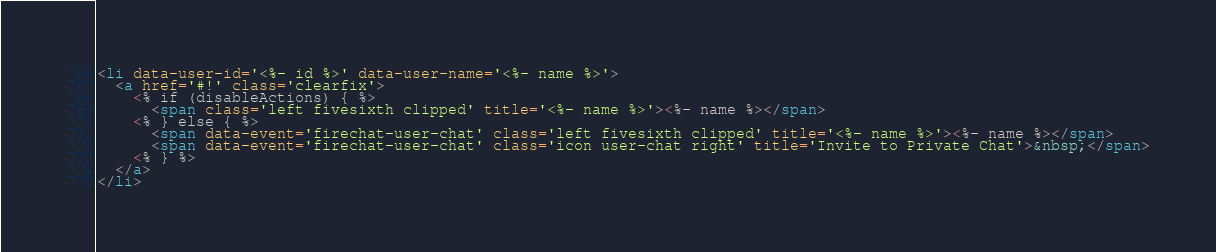Convert code to text. <code><loc_0><loc_0><loc_500><loc_500><_HTML_><li data-user-id='<%- id %>' data-user-name='<%- name %>'>
  <a href='#!' class='clearfix'>
    <% if (disableActions) { %>
      <span class='left fivesixth clipped' title='<%- name %>'><%- name %></span>
    <% } else { %>
      <span data-event='firechat-user-chat' class='left fivesixth clipped' title='<%- name %>'><%- name %></span>
      <span data-event='firechat-user-chat' class='icon user-chat right' title='Invite to Private Chat'>&nbsp;</span>
    <% } %>
  </a>
</li></code> 